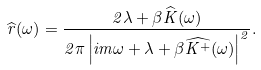<formula> <loc_0><loc_0><loc_500><loc_500>\widehat { r } ( \omega ) = \frac { 2 \lambda + \beta \widehat { K } ( \omega ) } { 2 \pi \left | i m \omega + \lambda + \beta \widehat { K ^ { + } } ( \omega ) \right | ^ { 2 } } .</formula> 